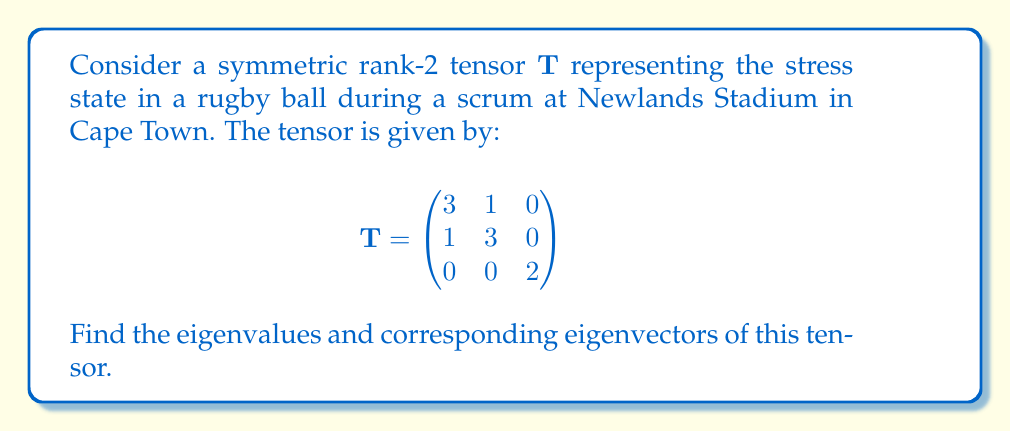Give your solution to this math problem. To find the eigenvalues and eigenvectors of the symmetric rank-2 tensor $\mathbf{T}$, we follow these steps:

1) First, we find the eigenvalues by solving the characteristic equation:
   $$\det(\mathbf{T} - \lambda \mathbf{I}) = 0$$

   where $\lambda$ represents the eigenvalues and $\mathbf{I}$ is the 3x3 identity matrix.

2) Expanding the determinant:
   $$\begin{vmatrix}
   3-\lambda & 1 & 0 \\
   1 & 3-\lambda & 0 \\
   0 & 0 & 2-\lambda
   \end{vmatrix} = 0$$

3) This gives us:
   $$(3-\lambda)^2 - 1^2)(2-\lambda) = 0$$
   $$(9-6\lambda+\lambda^2-1)(2-\lambda) = 0$$
   $$(\lambda^2-6\lambda+8)(2-\lambda) = 0$$
   $$(\lambda-4)(\lambda-2)(2-\lambda) = 0$$

4) Solving this equation, we get the eigenvalues:
   $$\lambda_1 = 4, \lambda_2 = 2, \lambda_3 = 2$$

5) Now, for each eigenvalue, we find the corresponding eigenvector $\mathbf{v}$ by solving:
   $$(\mathbf{T} - \lambda \mathbf{I})\mathbf{v} = \mathbf{0}$$

6) For $\lambda_1 = 4$:
   $$\begin{pmatrix}
   -1 & 1 & 0 \\
   1 & -1 & 0 \\
   0 & 0 & -2
   \end{pmatrix}\begin{pmatrix}
   v_1 \\ v_2 \\ v_3
   \end{pmatrix} = \begin{pmatrix}
   0 \\ 0 \\ 0
   \end{pmatrix}$$

   This gives us: $v_1 = v_2, v_3 = 0$. We can choose $\mathbf{v}_1 = (1, 1, 0)$.

7) For $\lambda_2 = \lambda_3 = 2$:
   $$\begin{pmatrix}
   1 & 1 & 0 \\
   1 & 1 & 0 \\
   0 & 0 & 0
   \end{pmatrix}\begin{pmatrix}
   v_1 \\ v_2 \\ v_3
   \end{pmatrix} = \begin{pmatrix}
   0 \\ 0 \\ 0
   \end{pmatrix}$$

   This gives us two linearly independent eigenvectors:
   $\mathbf{v}_2 = (-1, 1, 0)$ and $\mathbf{v}_3 = (0, 0, 1)$.
Answer: Eigenvalues: $\lambda_1 = 4, \lambda_2 = 2, \lambda_3 = 2$
Eigenvectors: $\mathbf{v}_1 = (1, 1, 0), \mathbf{v}_2 = (-1, 1, 0), \mathbf{v}_3 = (0, 0, 1)$ 